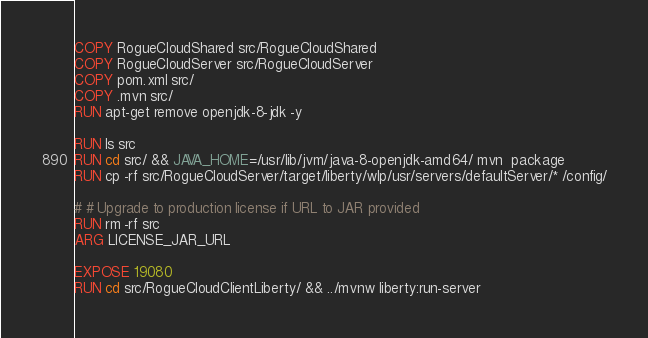<code> <loc_0><loc_0><loc_500><loc_500><_Dockerfile_>COPY RogueCloudShared src/RogueCloudShared
COPY RogueCloudServer src/RogueCloudServer
COPY pom.xml src/
COPY .mvn src/
RUN apt-get remove openjdk-8-jdk -y

RUN ls src
RUN cd src/ && JAVA_HOME=/usr/lib/jvm/java-8-openjdk-amd64/ mvn  package
RUN cp -rf src/RogueCloudServer/target/liberty/wlp/usr/servers/defaultServer/* /config/

# # Upgrade to production license if URL to JAR provided
RUN rm -rf src
ARG LICENSE_JAR_URL

EXPOSE 19080
RUN cd src/RogueCloudClientLiberty/ && ../mvnw liberty:run-server
</code> 